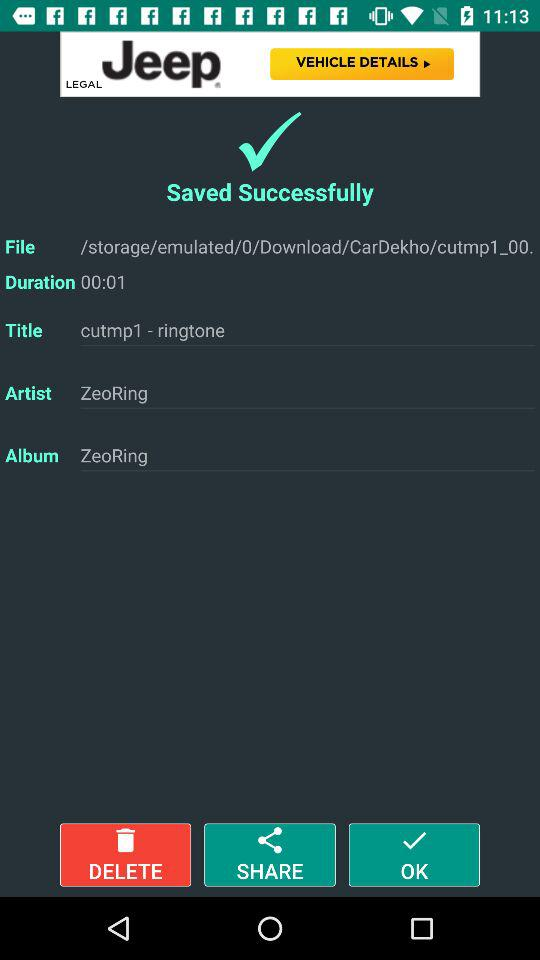What's the artist name? Based on the information visible in the screenshot of the music file, the name listed under 'Artist' is 'ZeoRing.' It is worth noting that 'ZeoRing' is also mentioned as the 'Album' name, which could imply that 'ZeoRing' is the artist's pseudonym or a placeholder used by the software for both fields if the actual artist's name is not provided. 